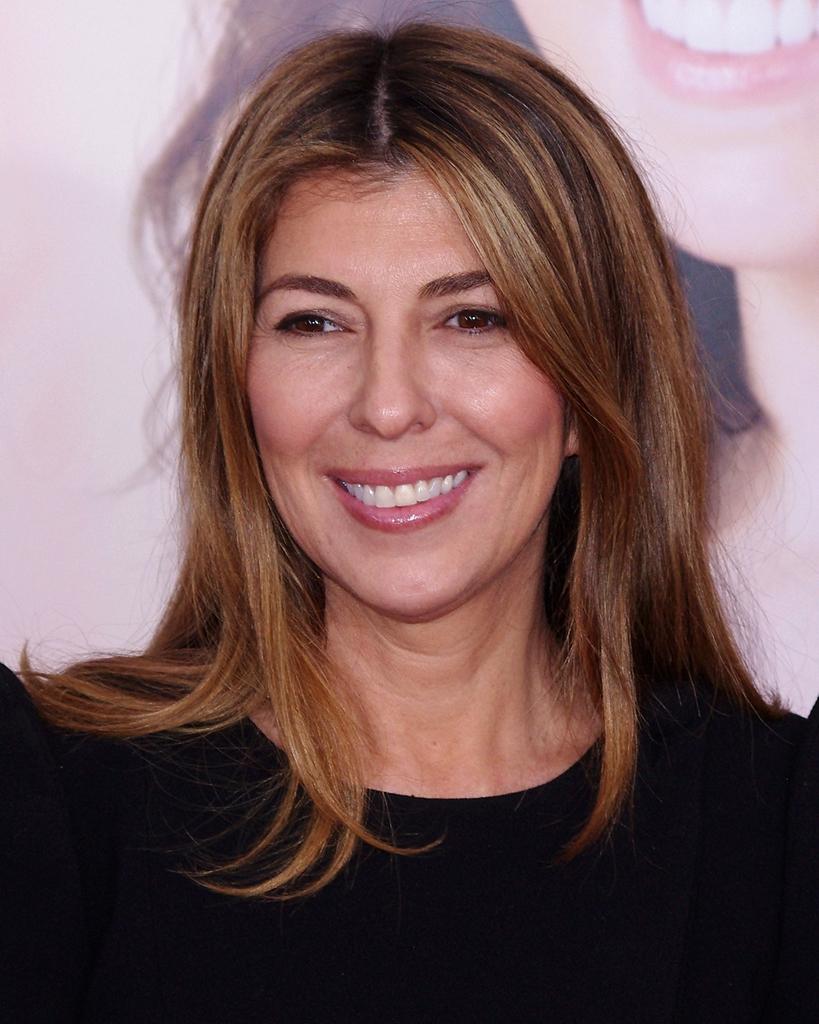Describe this image in one or two sentences. In the center of the image there is a lady wearing a black color dress. In the background of the image there is a banner on which there is a depiction of a lady. 